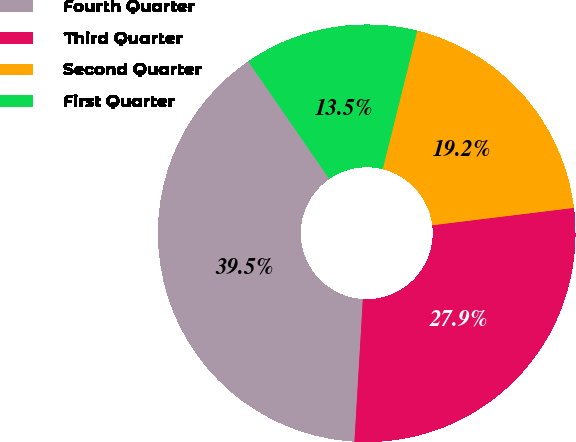Convert chart to OTSL. <chart><loc_0><loc_0><loc_500><loc_500><pie_chart><fcel>Fourth Quarter<fcel>Third Quarter<fcel>Second Quarter<fcel>First Quarter<nl><fcel>39.46%<fcel>27.88%<fcel>19.17%<fcel>13.49%<nl></chart> 